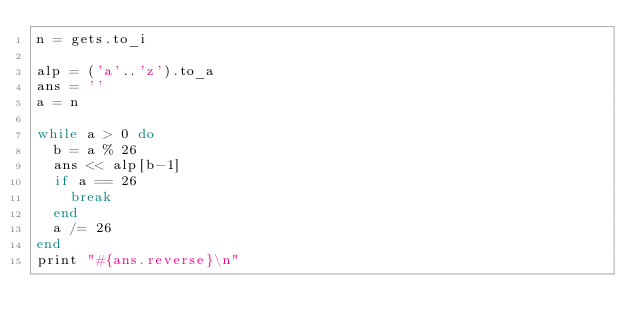<code> <loc_0><loc_0><loc_500><loc_500><_Ruby_>n = gets.to_i

alp = ('a'..'z').to_a
ans = ''
a = n

while a > 0 do
  b = a % 26
  ans << alp[b-1]
  if a == 26
    break
  end
  a /= 26
end
print "#{ans.reverse}\n"</code> 